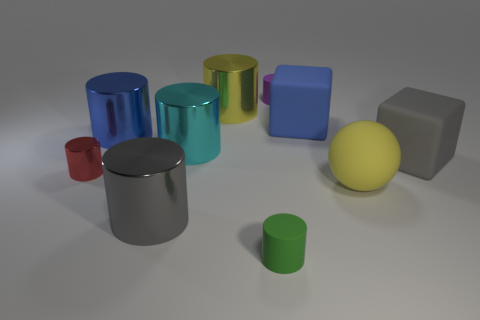How many tiny red shiny things are the same shape as the big gray metallic object?
Offer a terse response. 1. Is there a large yellow shiny thing?
Give a very brief answer. Yes. Is the red object made of the same material as the tiny thing behind the large gray rubber object?
Provide a short and direct response. No. There is a yellow cylinder that is the same size as the gray cube; what is it made of?
Give a very brief answer. Metal. Is there a cyan cylinder that has the same material as the red object?
Your answer should be very brief. Yes. Is there a small thing that is behind the small matte object in front of the yellow thing on the right side of the green cylinder?
Keep it short and to the point. Yes. What is the shape of the yellow metallic object that is the same size as the gray matte thing?
Offer a very short reply. Cylinder. There is a blue thing that is right of the large cyan cylinder; is its size the same as the gray thing that is behind the gray cylinder?
Offer a very short reply. Yes. How many small green matte spheres are there?
Provide a succinct answer. 0. What is the size of the rubber cube behind the cube in front of the cube behind the big gray rubber thing?
Make the answer very short. Large. 